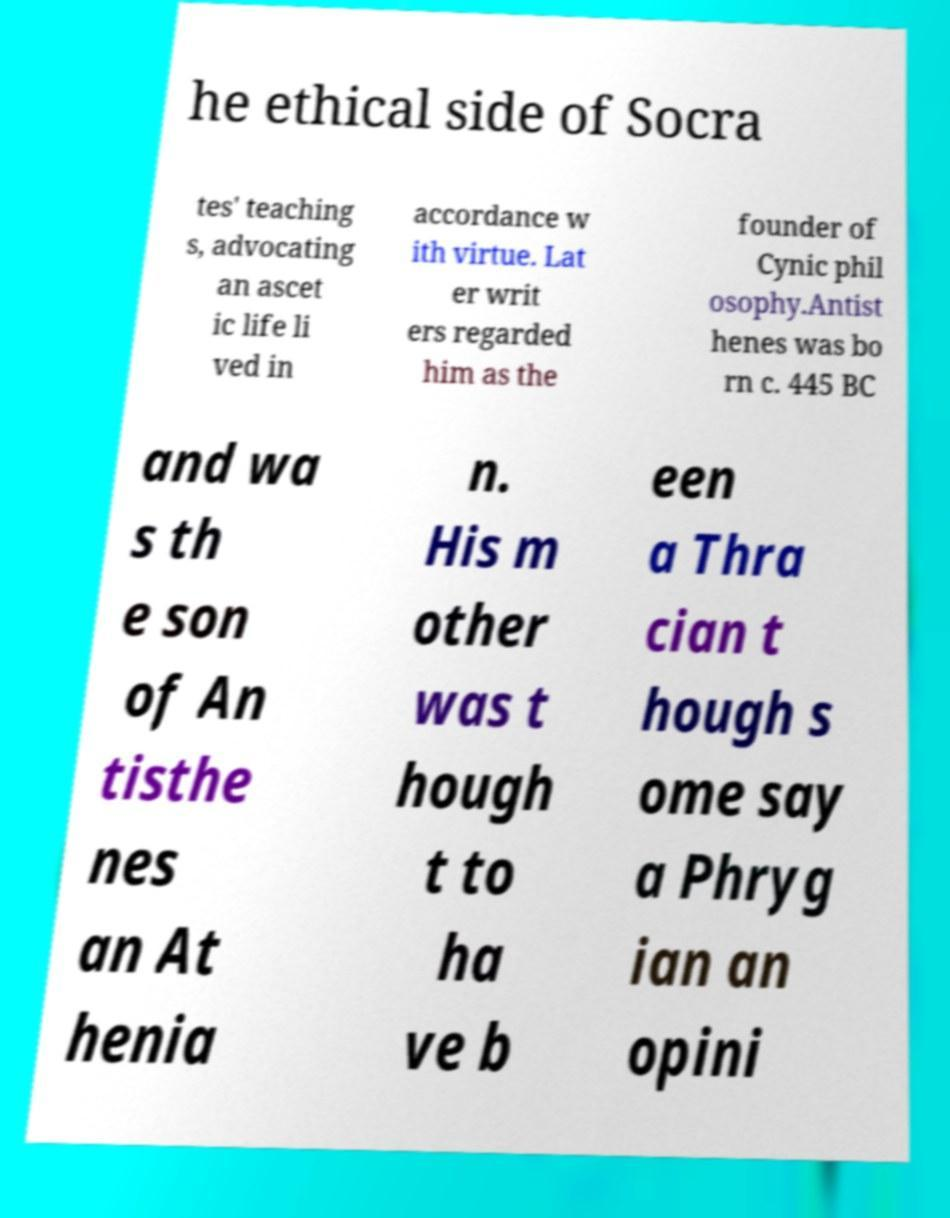Could you extract and type out the text from this image? he ethical side of Socra tes' teaching s, advocating an ascet ic life li ved in accordance w ith virtue. Lat er writ ers regarded him as the founder of Cynic phil osophy.Antist henes was bo rn c. 445 BC and wa s th e son of An tisthe nes an At henia n. His m other was t hough t to ha ve b een a Thra cian t hough s ome say a Phryg ian an opini 